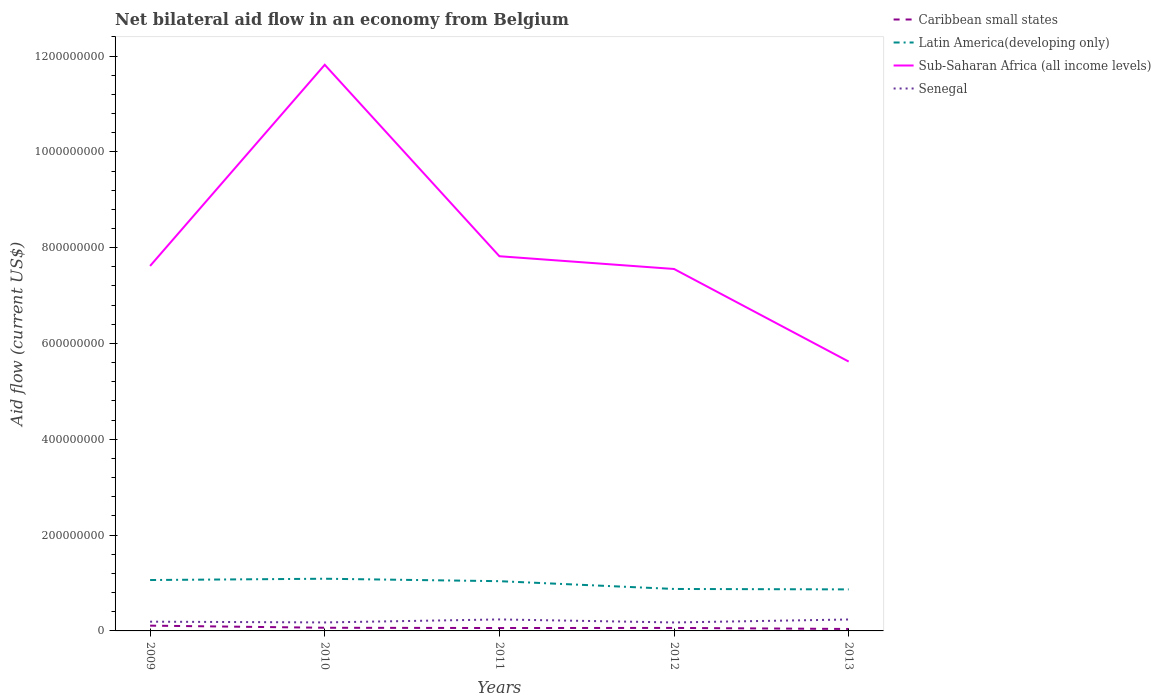Does the line corresponding to Latin America(developing only) intersect with the line corresponding to Senegal?
Your answer should be compact. No. Is the number of lines equal to the number of legend labels?
Give a very brief answer. Yes. Across all years, what is the maximum net bilateral aid flow in Caribbean small states?
Give a very brief answer. 4.07e+06. What is the total net bilateral aid flow in Latin America(developing only) in the graph?
Your response must be concise. 2.14e+07. What is the difference between the highest and the second highest net bilateral aid flow in Latin America(developing only)?
Offer a very short reply. 2.22e+07. How many lines are there?
Offer a terse response. 4. Are the values on the major ticks of Y-axis written in scientific E-notation?
Keep it short and to the point. No. Where does the legend appear in the graph?
Provide a succinct answer. Top right. How many legend labels are there?
Your answer should be very brief. 4. What is the title of the graph?
Your answer should be very brief. Net bilateral aid flow in an economy from Belgium. What is the label or title of the Y-axis?
Keep it short and to the point. Aid flow (current US$). What is the Aid flow (current US$) in Caribbean small states in 2009?
Ensure brevity in your answer.  1.10e+07. What is the Aid flow (current US$) of Latin America(developing only) in 2009?
Your answer should be very brief. 1.06e+08. What is the Aid flow (current US$) of Sub-Saharan Africa (all income levels) in 2009?
Offer a very short reply. 7.62e+08. What is the Aid flow (current US$) of Senegal in 2009?
Offer a very short reply. 1.93e+07. What is the Aid flow (current US$) of Caribbean small states in 2010?
Your answer should be compact. 6.60e+06. What is the Aid flow (current US$) of Latin America(developing only) in 2010?
Your response must be concise. 1.09e+08. What is the Aid flow (current US$) of Sub-Saharan Africa (all income levels) in 2010?
Offer a very short reply. 1.18e+09. What is the Aid flow (current US$) in Senegal in 2010?
Your answer should be very brief. 1.77e+07. What is the Aid flow (current US$) of Caribbean small states in 2011?
Provide a succinct answer. 6.04e+06. What is the Aid flow (current US$) of Latin America(developing only) in 2011?
Your answer should be very brief. 1.04e+08. What is the Aid flow (current US$) in Sub-Saharan Africa (all income levels) in 2011?
Ensure brevity in your answer.  7.82e+08. What is the Aid flow (current US$) in Senegal in 2011?
Provide a short and direct response. 2.40e+07. What is the Aid flow (current US$) of Caribbean small states in 2012?
Give a very brief answer. 6.26e+06. What is the Aid flow (current US$) in Latin America(developing only) in 2012?
Provide a short and direct response. 8.76e+07. What is the Aid flow (current US$) in Sub-Saharan Africa (all income levels) in 2012?
Provide a succinct answer. 7.56e+08. What is the Aid flow (current US$) in Senegal in 2012?
Ensure brevity in your answer.  1.77e+07. What is the Aid flow (current US$) of Caribbean small states in 2013?
Ensure brevity in your answer.  4.07e+06. What is the Aid flow (current US$) in Latin America(developing only) in 2013?
Provide a succinct answer. 8.67e+07. What is the Aid flow (current US$) in Sub-Saharan Africa (all income levels) in 2013?
Ensure brevity in your answer.  5.62e+08. What is the Aid flow (current US$) of Senegal in 2013?
Provide a succinct answer. 2.39e+07. Across all years, what is the maximum Aid flow (current US$) of Caribbean small states?
Give a very brief answer. 1.10e+07. Across all years, what is the maximum Aid flow (current US$) of Latin America(developing only)?
Keep it short and to the point. 1.09e+08. Across all years, what is the maximum Aid flow (current US$) of Sub-Saharan Africa (all income levels)?
Give a very brief answer. 1.18e+09. Across all years, what is the maximum Aid flow (current US$) in Senegal?
Provide a succinct answer. 2.40e+07. Across all years, what is the minimum Aid flow (current US$) in Caribbean small states?
Your response must be concise. 4.07e+06. Across all years, what is the minimum Aid flow (current US$) in Latin America(developing only)?
Provide a short and direct response. 8.67e+07. Across all years, what is the minimum Aid flow (current US$) in Sub-Saharan Africa (all income levels)?
Keep it short and to the point. 5.62e+08. Across all years, what is the minimum Aid flow (current US$) in Senegal?
Your answer should be compact. 1.77e+07. What is the total Aid flow (current US$) of Caribbean small states in the graph?
Offer a very short reply. 3.40e+07. What is the total Aid flow (current US$) in Latin America(developing only) in the graph?
Offer a terse response. 4.93e+08. What is the total Aid flow (current US$) of Sub-Saharan Africa (all income levels) in the graph?
Provide a succinct answer. 4.04e+09. What is the total Aid flow (current US$) in Senegal in the graph?
Keep it short and to the point. 1.03e+08. What is the difference between the Aid flow (current US$) of Caribbean small states in 2009 and that in 2010?
Provide a short and direct response. 4.42e+06. What is the difference between the Aid flow (current US$) of Latin America(developing only) in 2009 and that in 2010?
Provide a short and direct response. -2.70e+06. What is the difference between the Aid flow (current US$) of Sub-Saharan Africa (all income levels) in 2009 and that in 2010?
Give a very brief answer. -4.20e+08. What is the difference between the Aid flow (current US$) in Senegal in 2009 and that in 2010?
Ensure brevity in your answer.  1.56e+06. What is the difference between the Aid flow (current US$) in Caribbean small states in 2009 and that in 2011?
Offer a terse response. 4.98e+06. What is the difference between the Aid flow (current US$) in Latin America(developing only) in 2009 and that in 2011?
Your response must be concise. 2.40e+06. What is the difference between the Aid flow (current US$) in Sub-Saharan Africa (all income levels) in 2009 and that in 2011?
Provide a short and direct response. -2.03e+07. What is the difference between the Aid flow (current US$) of Senegal in 2009 and that in 2011?
Provide a short and direct response. -4.68e+06. What is the difference between the Aid flow (current US$) of Caribbean small states in 2009 and that in 2012?
Make the answer very short. 4.76e+06. What is the difference between the Aid flow (current US$) in Latin America(developing only) in 2009 and that in 2012?
Provide a succinct answer. 1.86e+07. What is the difference between the Aid flow (current US$) of Sub-Saharan Africa (all income levels) in 2009 and that in 2012?
Offer a very short reply. 6.34e+06. What is the difference between the Aid flow (current US$) of Senegal in 2009 and that in 2012?
Provide a succinct answer. 1.63e+06. What is the difference between the Aid flow (current US$) in Caribbean small states in 2009 and that in 2013?
Keep it short and to the point. 6.95e+06. What is the difference between the Aid flow (current US$) in Latin America(developing only) in 2009 and that in 2013?
Keep it short and to the point. 1.96e+07. What is the difference between the Aid flow (current US$) in Sub-Saharan Africa (all income levels) in 2009 and that in 2013?
Provide a short and direct response. 2.00e+08. What is the difference between the Aid flow (current US$) of Senegal in 2009 and that in 2013?
Offer a very short reply. -4.57e+06. What is the difference between the Aid flow (current US$) of Caribbean small states in 2010 and that in 2011?
Your answer should be very brief. 5.60e+05. What is the difference between the Aid flow (current US$) in Latin America(developing only) in 2010 and that in 2011?
Ensure brevity in your answer.  5.10e+06. What is the difference between the Aid flow (current US$) of Sub-Saharan Africa (all income levels) in 2010 and that in 2011?
Your answer should be very brief. 4.00e+08. What is the difference between the Aid flow (current US$) in Senegal in 2010 and that in 2011?
Offer a terse response. -6.24e+06. What is the difference between the Aid flow (current US$) of Latin America(developing only) in 2010 and that in 2012?
Give a very brief answer. 2.14e+07. What is the difference between the Aid flow (current US$) in Sub-Saharan Africa (all income levels) in 2010 and that in 2012?
Your response must be concise. 4.26e+08. What is the difference between the Aid flow (current US$) of Senegal in 2010 and that in 2012?
Make the answer very short. 7.00e+04. What is the difference between the Aid flow (current US$) of Caribbean small states in 2010 and that in 2013?
Provide a succinct answer. 2.53e+06. What is the difference between the Aid flow (current US$) of Latin America(developing only) in 2010 and that in 2013?
Ensure brevity in your answer.  2.22e+07. What is the difference between the Aid flow (current US$) of Sub-Saharan Africa (all income levels) in 2010 and that in 2013?
Provide a succinct answer. 6.19e+08. What is the difference between the Aid flow (current US$) in Senegal in 2010 and that in 2013?
Your answer should be compact. -6.13e+06. What is the difference between the Aid flow (current US$) in Caribbean small states in 2011 and that in 2012?
Provide a short and direct response. -2.20e+05. What is the difference between the Aid flow (current US$) in Latin America(developing only) in 2011 and that in 2012?
Ensure brevity in your answer.  1.62e+07. What is the difference between the Aid flow (current US$) of Sub-Saharan Africa (all income levels) in 2011 and that in 2012?
Your response must be concise. 2.66e+07. What is the difference between the Aid flow (current US$) of Senegal in 2011 and that in 2012?
Your response must be concise. 6.31e+06. What is the difference between the Aid flow (current US$) of Caribbean small states in 2011 and that in 2013?
Keep it short and to the point. 1.97e+06. What is the difference between the Aid flow (current US$) of Latin America(developing only) in 2011 and that in 2013?
Your answer should be compact. 1.72e+07. What is the difference between the Aid flow (current US$) in Sub-Saharan Africa (all income levels) in 2011 and that in 2013?
Keep it short and to the point. 2.20e+08. What is the difference between the Aid flow (current US$) of Caribbean small states in 2012 and that in 2013?
Offer a terse response. 2.19e+06. What is the difference between the Aid flow (current US$) in Latin America(developing only) in 2012 and that in 2013?
Your answer should be compact. 9.00e+05. What is the difference between the Aid flow (current US$) in Sub-Saharan Africa (all income levels) in 2012 and that in 2013?
Offer a terse response. 1.93e+08. What is the difference between the Aid flow (current US$) of Senegal in 2012 and that in 2013?
Offer a terse response. -6.20e+06. What is the difference between the Aid flow (current US$) in Caribbean small states in 2009 and the Aid flow (current US$) in Latin America(developing only) in 2010?
Make the answer very short. -9.79e+07. What is the difference between the Aid flow (current US$) in Caribbean small states in 2009 and the Aid flow (current US$) in Sub-Saharan Africa (all income levels) in 2010?
Provide a short and direct response. -1.17e+09. What is the difference between the Aid flow (current US$) of Caribbean small states in 2009 and the Aid flow (current US$) of Senegal in 2010?
Your response must be concise. -6.72e+06. What is the difference between the Aid flow (current US$) in Latin America(developing only) in 2009 and the Aid flow (current US$) in Sub-Saharan Africa (all income levels) in 2010?
Provide a short and direct response. -1.08e+09. What is the difference between the Aid flow (current US$) in Latin America(developing only) in 2009 and the Aid flow (current US$) in Senegal in 2010?
Your answer should be compact. 8.85e+07. What is the difference between the Aid flow (current US$) of Sub-Saharan Africa (all income levels) in 2009 and the Aid flow (current US$) of Senegal in 2010?
Provide a succinct answer. 7.44e+08. What is the difference between the Aid flow (current US$) in Caribbean small states in 2009 and the Aid flow (current US$) in Latin America(developing only) in 2011?
Your answer should be compact. -9.28e+07. What is the difference between the Aid flow (current US$) of Caribbean small states in 2009 and the Aid flow (current US$) of Sub-Saharan Africa (all income levels) in 2011?
Your answer should be very brief. -7.71e+08. What is the difference between the Aid flow (current US$) in Caribbean small states in 2009 and the Aid flow (current US$) in Senegal in 2011?
Make the answer very short. -1.30e+07. What is the difference between the Aid flow (current US$) in Latin America(developing only) in 2009 and the Aid flow (current US$) in Sub-Saharan Africa (all income levels) in 2011?
Offer a terse response. -6.76e+08. What is the difference between the Aid flow (current US$) in Latin America(developing only) in 2009 and the Aid flow (current US$) in Senegal in 2011?
Provide a succinct answer. 8.23e+07. What is the difference between the Aid flow (current US$) in Sub-Saharan Africa (all income levels) in 2009 and the Aid flow (current US$) in Senegal in 2011?
Provide a succinct answer. 7.38e+08. What is the difference between the Aid flow (current US$) of Caribbean small states in 2009 and the Aid flow (current US$) of Latin America(developing only) in 2012?
Your response must be concise. -7.66e+07. What is the difference between the Aid flow (current US$) in Caribbean small states in 2009 and the Aid flow (current US$) in Sub-Saharan Africa (all income levels) in 2012?
Your answer should be very brief. -7.44e+08. What is the difference between the Aid flow (current US$) in Caribbean small states in 2009 and the Aid flow (current US$) in Senegal in 2012?
Ensure brevity in your answer.  -6.65e+06. What is the difference between the Aid flow (current US$) in Latin America(developing only) in 2009 and the Aid flow (current US$) in Sub-Saharan Africa (all income levels) in 2012?
Provide a short and direct response. -6.49e+08. What is the difference between the Aid flow (current US$) of Latin America(developing only) in 2009 and the Aid flow (current US$) of Senegal in 2012?
Offer a very short reply. 8.86e+07. What is the difference between the Aid flow (current US$) of Sub-Saharan Africa (all income levels) in 2009 and the Aid flow (current US$) of Senegal in 2012?
Give a very brief answer. 7.44e+08. What is the difference between the Aid flow (current US$) of Caribbean small states in 2009 and the Aid flow (current US$) of Latin America(developing only) in 2013?
Your answer should be very brief. -7.57e+07. What is the difference between the Aid flow (current US$) in Caribbean small states in 2009 and the Aid flow (current US$) in Sub-Saharan Africa (all income levels) in 2013?
Your response must be concise. -5.51e+08. What is the difference between the Aid flow (current US$) in Caribbean small states in 2009 and the Aid flow (current US$) in Senegal in 2013?
Your answer should be very brief. -1.28e+07. What is the difference between the Aid flow (current US$) of Latin America(developing only) in 2009 and the Aid flow (current US$) of Sub-Saharan Africa (all income levels) in 2013?
Offer a very short reply. -4.56e+08. What is the difference between the Aid flow (current US$) of Latin America(developing only) in 2009 and the Aid flow (current US$) of Senegal in 2013?
Ensure brevity in your answer.  8.24e+07. What is the difference between the Aid flow (current US$) in Sub-Saharan Africa (all income levels) in 2009 and the Aid flow (current US$) in Senegal in 2013?
Provide a short and direct response. 7.38e+08. What is the difference between the Aid flow (current US$) in Caribbean small states in 2010 and the Aid flow (current US$) in Latin America(developing only) in 2011?
Your answer should be very brief. -9.72e+07. What is the difference between the Aid flow (current US$) of Caribbean small states in 2010 and the Aid flow (current US$) of Sub-Saharan Africa (all income levels) in 2011?
Your response must be concise. -7.76e+08. What is the difference between the Aid flow (current US$) in Caribbean small states in 2010 and the Aid flow (current US$) in Senegal in 2011?
Ensure brevity in your answer.  -1.74e+07. What is the difference between the Aid flow (current US$) in Latin America(developing only) in 2010 and the Aid flow (current US$) in Sub-Saharan Africa (all income levels) in 2011?
Offer a terse response. -6.73e+08. What is the difference between the Aid flow (current US$) of Latin America(developing only) in 2010 and the Aid flow (current US$) of Senegal in 2011?
Make the answer very short. 8.50e+07. What is the difference between the Aid flow (current US$) of Sub-Saharan Africa (all income levels) in 2010 and the Aid flow (current US$) of Senegal in 2011?
Keep it short and to the point. 1.16e+09. What is the difference between the Aid flow (current US$) of Caribbean small states in 2010 and the Aid flow (current US$) of Latin America(developing only) in 2012?
Keep it short and to the point. -8.10e+07. What is the difference between the Aid flow (current US$) in Caribbean small states in 2010 and the Aid flow (current US$) in Sub-Saharan Africa (all income levels) in 2012?
Make the answer very short. -7.49e+08. What is the difference between the Aid flow (current US$) in Caribbean small states in 2010 and the Aid flow (current US$) in Senegal in 2012?
Provide a short and direct response. -1.11e+07. What is the difference between the Aid flow (current US$) in Latin America(developing only) in 2010 and the Aid flow (current US$) in Sub-Saharan Africa (all income levels) in 2012?
Give a very brief answer. -6.47e+08. What is the difference between the Aid flow (current US$) of Latin America(developing only) in 2010 and the Aid flow (current US$) of Senegal in 2012?
Give a very brief answer. 9.13e+07. What is the difference between the Aid flow (current US$) in Sub-Saharan Africa (all income levels) in 2010 and the Aid flow (current US$) in Senegal in 2012?
Offer a very short reply. 1.16e+09. What is the difference between the Aid flow (current US$) of Caribbean small states in 2010 and the Aid flow (current US$) of Latin America(developing only) in 2013?
Offer a terse response. -8.01e+07. What is the difference between the Aid flow (current US$) of Caribbean small states in 2010 and the Aid flow (current US$) of Sub-Saharan Africa (all income levels) in 2013?
Give a very brief answer. -5.56e+08. What is the difference between the Aid flow (current US$) in Caribbean small states in 2010 and the Aid flow (current US$) in Senegal in 2013?
Provide a succinct answer. -1.73e+07. What is the difference between the Aid flow (current US$) in Latin America(developing only) in 2010 and the Aid flow (current US$) in Sub-Saharan Africa (all income levels) in 2013?
Your answer should be compact. -4.53e+08. What is the difference between the Aid flow (current US$) of Latin America(developing only) in 2010 and the Aid flow (current US$) of Senegal in 2013?
Provide a succinct answer. 8.51e+07. What is the difference between the Aid flow (current US$) in Sub-Saharan Africa (all income levels) in 2010 and the Aid flow (current US$) in Senegal in 2013?
Give a very brief answer. 1.16e+09. What is the difference between the Aid flow (current US$) of Caribbean small states in 2011 and the Aid flow (current US$) of Latin America(developing only) in 2012?
Offer a very short reply. -8.16e+07. What is the difference between the Aid flow (current US$) in Caribbean small states in 2011 and the Aid flow (current US$) in Sub-Saharan Africa (all income levels) in 2012?
Provide a succinct answer. -7.49e+08. What is the difference between the Aid flow (current US$) of Caribbean small states in 2011 and the Aid flow (current US$) of Senegal in 2012?
Your response must be concise. -1.16e+07. What is the difference between the Aid flow (current US$) in Latin America(developing only) in 2011 and the Aid flow (current US$) in Sub-Saharan Africa (all income levels) in 2012?
Keep it short and to the point. -6.52e+08. What is the difference between the Aid flow (current US$) of Latin America(developing only) in 2011 and the Aid flow (current US$) of Senegal in 2012?
Give a very brief answer. 8.62e+07. What is the difference between the Aid flow (current US$) in Sub-Saharan Africa (all income levels) in 2011 and the Aid flow (current US$) in Senegal in 2012?
Make the answer very short. 7.64e+08. What is the difference between the Aid flow (current US$) in Caribbean small states in 2011 and the Aid flow (current US$) in Latin America(developing only) in 2013?
Offer a very short reply. -8.06e+07. What is the difference between the Aid flow (current US$) in Caribbean small states in 2011 and the Aid flow (current US$) in Sub-Saharan Africa (all income levels) in 2013?
Your answer should be compact. -5.56e+08. What is the difference between the Aid flow (current US$) in Caribbean small states in 2011 and the Aid flow (current US$) in Senegal in 2013?
Give a very brief answer. -1.78e+07. What is the difference between the Aid flow (current US$) of Latin America(developing only) in 2011 and the Aid flow (current US$) of Sub-Saharan Africa (all income levels) in 2013?
Give a very brief answer. -4.58e+08. What is the difference between the Aid flow (current US$) in Latin America(developing only) in 2011 and the Aid flow (current US$) in Senegal in 2013?
Keep it short and to the point. 8.00e+07. What is the difference between the Aid flow (current US$) in Sub-Saharan Africa (all income levels) in 2011 and the Aid flow (current US$) in Senegal in 2013?
Provide a succinct answer. 7.58e+08. What is the difference between the Aid flow (current US$) of Caribbean small states in 2012 and the Aid flow (current US$) of Latin America(developing only) in 2013?
Provide a succinct answer. -8.04e+07. What is the difference between the Aid flow (current US$) of Caribbean small states in 2012 and the Aid flow (current US$) of Sub-Saharan Africa (all income levels) in 2013?
Keep it short and to the point. -5.56e+08. What is the difference between the Aid flow (current US$) of Caribbean small states in 2012 and the Aid flow (current US$) of Senegal in 2013?
Offer a terse response. -1.76e+07. What is the difference between the Aid flow (current US$) of Latin America(developing only) in 2012 and the Aid flow (current US$) of Sub-Saharan Africa (all income levels) in 2013?
Give a very brief answer. -4.75e+08. What is the difference between the Aid flow (current US$) in Latin America(developing only) in 2012 and the Aid flow (current US$) in Senegal in 2013?
Your answer should be very brief. 6.37e+07. What is the difference between the Aid flow (current US$) of Sub-Saharan Africa (all income levels) in 2012 and the Aid flow (current US$) of Senegal in 2013?
Ensure brevity in your answer.  7.32e+08. What is the average Aid flow (current US$) of Caribbean small states per year?
Provide a short and direct response. 6.80e+06. What is the average Aid flow (current US$) of Latin America(developing only) per year?
Provide a succinct answer. 9.87e+07. What is the average Aid flow (current US$) of Sub-Saharan Africa (all income levels) per year?
Give a very brief answer. 8.09e+08. What is the average Aid flow (current US$) in Senegal per year?
Give a very brief answer. 2.05e+07. In the year 2009, what is the difference between the Aid flow (current US$) of Caribbean small states and Aid flow (current US$) of Latin America(developing only)?
Give a very brief answer. -9.52e+07. In the year 2009, what is the difference between the Aid flow (current US$) of Caribbean small states and Aid flow (current US$) of Sub-Saharan Africa (all income levels)?
Keep it short and to the point. -7.51e+08. In the year 2009, what is the difference between the Aid flow (current US$) in Caribbean small states and Aid flow (current US$) in Senegal?
Provide a succinct answer. -8.28e+06. In the year 2009, what is the difference between the Aid flow (current US$) of Latin America(developing only) and Aid flow (current US$) of Sub-Saharan Africa (all income levels)?
Offer a very short reply. -6.56e+08. In the year 2009, what is the difference between the Aid flow (current US$) in Latin America(developing only) and Aid flow (current US$) in Senegal?
Your response must be concise. 8.69e+07. In the year 2009, what is the difference between the Aid flow (current US$) in Sub-Saharan Africa (all income levels) and Aid flow (current US$) in Senegal?
Offer a terse response. 7.43e+08. In the year 2010, what is the difference between the Aid flow (current US$) in Caribbean small states and Aid flow (current US$) in Latin America(developing only)?
Ensure brevity in your answer.  -1.02e+08. In the year 2010, what is the difference between the Aid flow (current US$) of Caribbean small states and Aid flow (current US$) of Sub-Saharan Africa (all income levels)?
Offer a terse response. -1.18e+09. In the year 2010, what is the difference between the Aid flow (current US$) in Caribbean small states and Aid flow (current US$) in Senegal?
Provide a short and direct response. -1.11e+07. In the year 2010, what is the difference between the Aid flow (current US$) in Latin America(developing only) and Aid flow (current US$) in Sub-Saharan Africa (all income levels)?
Offer a very short reply. -1.07e+09. In the year 2010, what is the difference between the Aid flow (current US$) in Latin America(developing only) and Aid flow (current US$) in Senegal?
Keep it short and to the point. 9.12e+07. In the year 2010, what is the difference between the Aid flow (current US$) of Sub-Saharan Africa (all income levels) and Aid flow (current US$) of Senegal?
Your answer should be very brief. 1.16e+09. In the year 2011, what is the difference between the Aid flow (current US$) in Caribbean small states and Aid flow (current US$) in Latin America(developing only)?
Offer a very short reply. -9.78e+07. In the year 2011, what is the difference between the Aid flow (current US$) of Caribbean small states and Aid flow (current US$) of Sub-Saharan Africa (all income levels)?
Keep it short and to the point. -7.76e+08. In the year 2011, what is the difference between the Aid flow (current US$) in Caribbean small states and Aid flow (current US$) in Senegal?
Provide a succinct answer. -1.79e+07. In the year 2011, what is the difference between the Aid flow (current US$) in Latin America(developing only) and Aid flow (current US$) in Sub-Saharan Africa (all income levels)?
Keep it short and to the point. -6.78e+08. In the year 2011, what is the difference between the Aid flow (current US$) of Latin America(developing only) and Aid flow (current US$) of Senegal?
Provide a short and direct response. 7.99e+07. In the year 2011, what is the difference between the Aid flow (current US$) of Sub-Saharan Africa (all income levels) and Aid flow (current US$) of Senegal?
Give a very brief answer. 7.58e+08. In the year 2012, what is the difference between the Aid flow (current US$) in Caribbean small states and Aid flow (current US$) in Latin America(developing only)?
Give a very brief answer. -8.13e+07. In the year 2012, what is the difference between the Aid flow (current US$) in Caribbean small states and Aid flow (current US$) in Sub-Saharan Africa (all income levels)?
Provide a succinct answer. -7.49e+08. In the year 2012, what is the difference between the Aid flow (current US$) of Caribbean small states and Aid flow (current US$) of Senegal?
Your answer should be compact. -1.14e+07. In the year 2012, what is the difference between the Aid flow (current US$) of Latin America(developing only) and Aid flow (current US$) of Sub-Saharan Africa (all income levels)?
Make the answer very short. -6.68e+08. In the year 2012, what is the difference between the Aid flow (current US$) in Latin America(developing only) and Aid flow (current US$) in Senegal?
Ensure brevity in your answer.  6.99e+07. In the year 2012, what is the difference between the Aid flow (current US$) in Sub-Saharan Africa (all income levels) and Aid flow (current US$) in Senegal?
Ensure brevity in your answer.  7.38e+08. In the year 2013, what is the difference between the Aid flow (current US$) in Caribbean small states and Aid flow (current US$) in Latin America(developing only)?
Your answer should be compact. -8.26e+07. In the year 2013, what is the difference between the Aid flow (current US$) in Caribbean small states and Aid flow (current US$) in Sub-Saharan Africa (all income levels)?
Provide a succinct answer. -5.58e+08. In the year 2013, what is the difference between the Aid flow (current US$) in Caribbean small states and Aid flow (current US$) in Senegal?
Make the answer very short. -1.98e+07. In the year 2013, what is the difference between the Aid flow (current US$) in Latin America(developing only) and Aid flow (current US$) in Sub-Saharan Africa (all income levels)?
Offer a very short reply. -4.76e+08. In the year 2013, what is the difference between the Aid flow (current US$) of Latin America(developing only) and Aid flow (current US$) of Senegal?
Your answer should be very brief. 6.28e+07. In the year 2013, what is the difference between the Aid flow (current US$) of Sub-Saharan Africa (all income levels) and Aid flow (current US$) of Senegal?
Offer a terse response. 5.38e+08. What is the ratio of the Aid flow (current US$) in Caribbean small states in 2009 to that in 2010?
Keep it short and to the point. 1.67. What is the ratio of the Aid flow (current US$) in Latin America(developing only) in 2009 to that in 2010?
Ensure brevity in your answer.  0.98. What is the ratio of the Aid flow (current US$) in Sub-Saharan Africa (all income levels) in 2009 to that in 2010?
Keep it short and to the point. 0.64. What is the ratio of the Aid flow (current US$) of Senegal in 2009 to that in 2010?
Your response must be concise. 1.09. What is the ratio of the Aid flow (current US$) of Caribbean small states in 2009 to that in 2011?
Your answer should be compact. 1.82. What is the ratio of the Aid flow (current US$) of Latin America(developing only) in 2009 to that in 2011?
Your response must be concise. 1.02. What is the ratio of the Aid flow (current US$) in Sub-Saharan Africa (all income levels) in 2009 to that in 2011?
Offer a terse response. 0.97. What is the ratio of the Aid flow (current US$) of Senegal in 2009 to that in 2011?
Ensure brevity in your answer.  0.8. What is the ratio of the Aid flow (current US$) of Caribbean small states in 2009 to that in 2012?
Keep it short and to the point. 1.76. What is the ratio of the Aid flow (current US$) of Latin America(developing only) in 2009 to that in 2012?
Your answer should be compact. 1.21. What is the ratio of the Aid flow (current US$) in Sub-Saharan Africa (all income levels) in 2009 to that in 2012?
Your answer should be compact. 1.01. What is the ratio of the Aid flow (current US$) of Senegal in 2009 to that in 2012?
Ensure brevity in your answer.  1.09. What is the ratio of the Aid flow (current US$) of Caribbean small states in 2009 to that in 2013?
Ensure brevity in your answer.  2.71. What is the ratio of the Aid flow (current US$) of Latin America(developing only) in 2009 to that in 2013?
Your answer should be compact. 1.23. What is the ratio of the Aid flow (current US$) of Sub-Saharan Africa (all income levels) in 2009 to that in 2013?
Offer a terse response. 1.35. What is the ratio of the Aid flow (current US$) of Senegal in 2009 to that in 2013?
Provide a short and direct response. 0.81. What is the ratio of the Aid flow (current US$) in Caribbean small states in 2010 to that in 2011?
Your response must be concise. 1.09. What is the ratio of the Aid flow (current US$) in Latin America(developing only) in 2010 to that in 2011?
Provide a succinct answer. 1.05. What is the ratio of the Aid flow (current US$) of Sub-Saharan Africa (all income levels) in 2010 to that in 2011?
Make the answer very short. 1.51. What is the ratio of the Aid flow (current US$) in Senegal in 2010 to that in 2011?
Ensure brevity in your answer.  0.74. What is the ratio of the Aid flow (current US$) of Caribbean small states in 2010 to that in 2012?
Your answer should be very brief. 1.05. What is the ratio of the Aid flow (current US$) of Latin America(developing only) in 2010 to that in 2012?
Your response must be concise. 1.24. What is the ratio of the Aid flow (current US$) of Sub-Saharan Africa (all income levels) in 2010 to that in 2012?
Give a very brief answer. 1.56. What is the ratio of the Aid flow (current US$) of Caribbean small states in 2010 to that in 2013?
Offer a terse response. 1.62. What is the ratio of the Aid flow (current US$) in Latin America(developing only) in 2010 to that in 2013?
Your answer should be very brief. 1.26. What is the ratio of the Aid flow (current US$) in Sub-Saharan Africa (all income levels) in 2010 to that in 2013?
Ensure brevity in your answer.  2.1. What is the ratio of the Aid flow (current US$) of Senegal in 2010 to that in 2013?
Your response must be concise. 0.74. What is the ratio of the Aid flow (current US$) in Caribbean small states in 2011 to that in 2012?
Give a very brief answer. 0.96. What is the ratio of the Aid flow (current US$) of Latin America(developing only) in 2011 to that in 2012?
Your answer should be very brief. 1.19. What is the ratio of the Aid flow (current US$) in Sub-Saharan Africa (all income levels) in 2011 to that in 2012?
Offer a very short reply. 1.04. What is the ratio of the Aid flow (current US$) of Senegal in 2011 to that in 2012?
Ensure brevity in your answer.  1.36. What is the ratio of the Aid flow (current US$) in Caribbean small states in 2011 to that in 2013?
Offer a very short reply. 1.48. What is the ratio of the Aid flow (current US$) in Latin America(developing only) in 2011 to that in 2013?
Your answer should be very brief. 1.2. What is the ratio of the Aid flow (current US$) in Sub-Saharan Africa (all income levels) in 2011 to that in 2013?
Your answer should be compact. 1.39. What is the ratio of the Aid flow (current US$) of Caribbean small states in 2012 to that in 2013?
Your response must be concise. 1.54. What is the ratio of the Aid flow (current US$) in Latin America(developing only) in 2012 to that in 2013?
Give a very brief answer. 1.01. What is the ratio of the Aid flow (current US$) in Sub-Saharan Africa (all income levels) in 2012 to that in 2013?
Offer a very short reply. 1.34. What is the ratio of the Aid flow (current US$) in Senegal in 2012 to that in 2013?
Your answer should be very brief. 0.74. What is the difference between the highest and the second highest Aid flow (current US$) in Caribbean small states?
Offer a very short reply. 4.42e+06. What is the difference between the highest and the second highest Aid flow (current US$) in Latin America(developing only)?
Your response must be concise. 2.70e+06. What is the difference between the highest and the second highest Aid flow (current US$) of Sub-Saharan Africa (all income levels)?
Offer a very short reply. 4.00e+08. What is the difference between the highest and the lowest Aid flow (current US$) in Caribbean small states?
Offer a very short reply. 6.95e+06. What is the difference between the highest and the lowest Aid flow (current US$) of Latin America(developing only)?
Provide a short and direct response. 2.22e+07. What is the difference between the highest and the lowest Aid flow (current US$) of Sub-Saharan Africa (all income levels)?
Ensure brevity in your answer.  6.19e+08. What is the difference between the highest and the lowest Aid flow (current US$) in Senegal?
Your answer should be compact. 6.31e+06. 